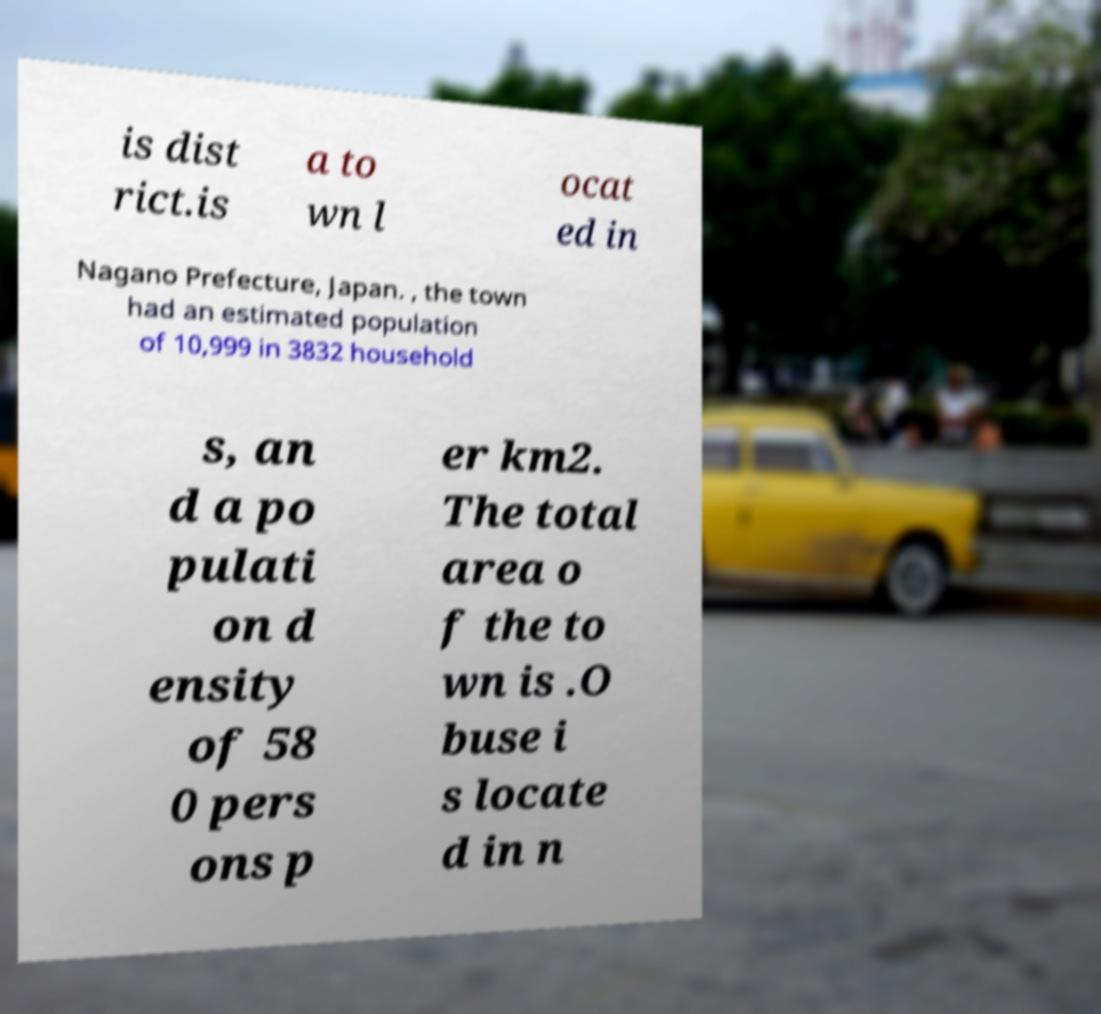There's text embedded in this image that I need extracted. Can you transcribe it verbatim? is dist rict.is a to wn l ocat ed in Nagano Prefecture, Japan. , the town had an estimated population of 10,999 in 3832 household s, an d a po pulati on d ensity of 58 0 pers ons p er km2. The total area o f the to wn is .O buse i s locate d in n 